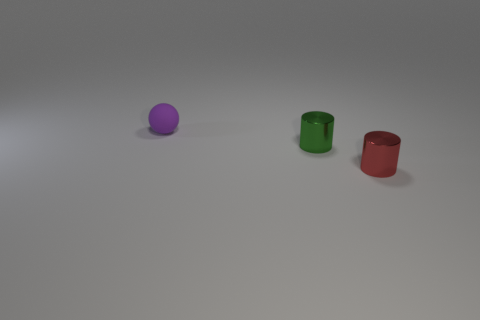There is a red thing that is the same shape as the green object; what is it made of?
Make the answer very short. Metal. What is the material of the small cylinder that is on the right side of the green cylinder?
Your answer should be compact. Metal. Are the tiny cylinder behind the red metallic object and the ball made of the same material?
Give a very brief answer. No. There is another metallic thing that is the same size as the red metallic thing; what is its shape?
Make the answer very short. Cylinder. What number of balls are the same color as the matte thing?
Offer a terse response. 0. Are there fewer green cylinders that are to the left of the sphere than tiny red objects left of the red object?
Your answer should be very brief. No. Are there any small matte objects to the right of the small ball?
Provide a short and direct response. No. Are there any tiny green shiny cylinders that are in front of the tiny cylinder behind the shiny thing right of the green cylinder?
Ensure brevity in your answer.  No. There is a metallic thing to the right of the green metal object; is its shape the same as the tiny purple rubber thing?
Provide a succinct answer. No. The other tiny thing that is the same material as the tiny red object is what color?
Keep it short and to the point. Green. 